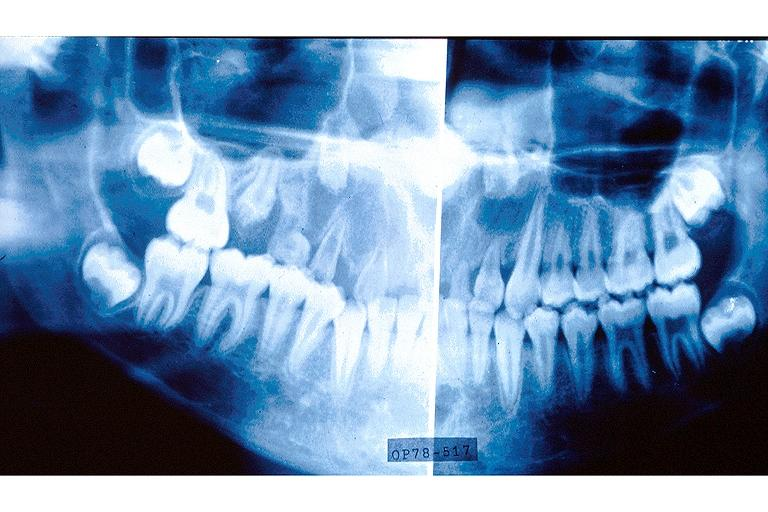s large gland present?
Answer the question using a single word or phrase. No 